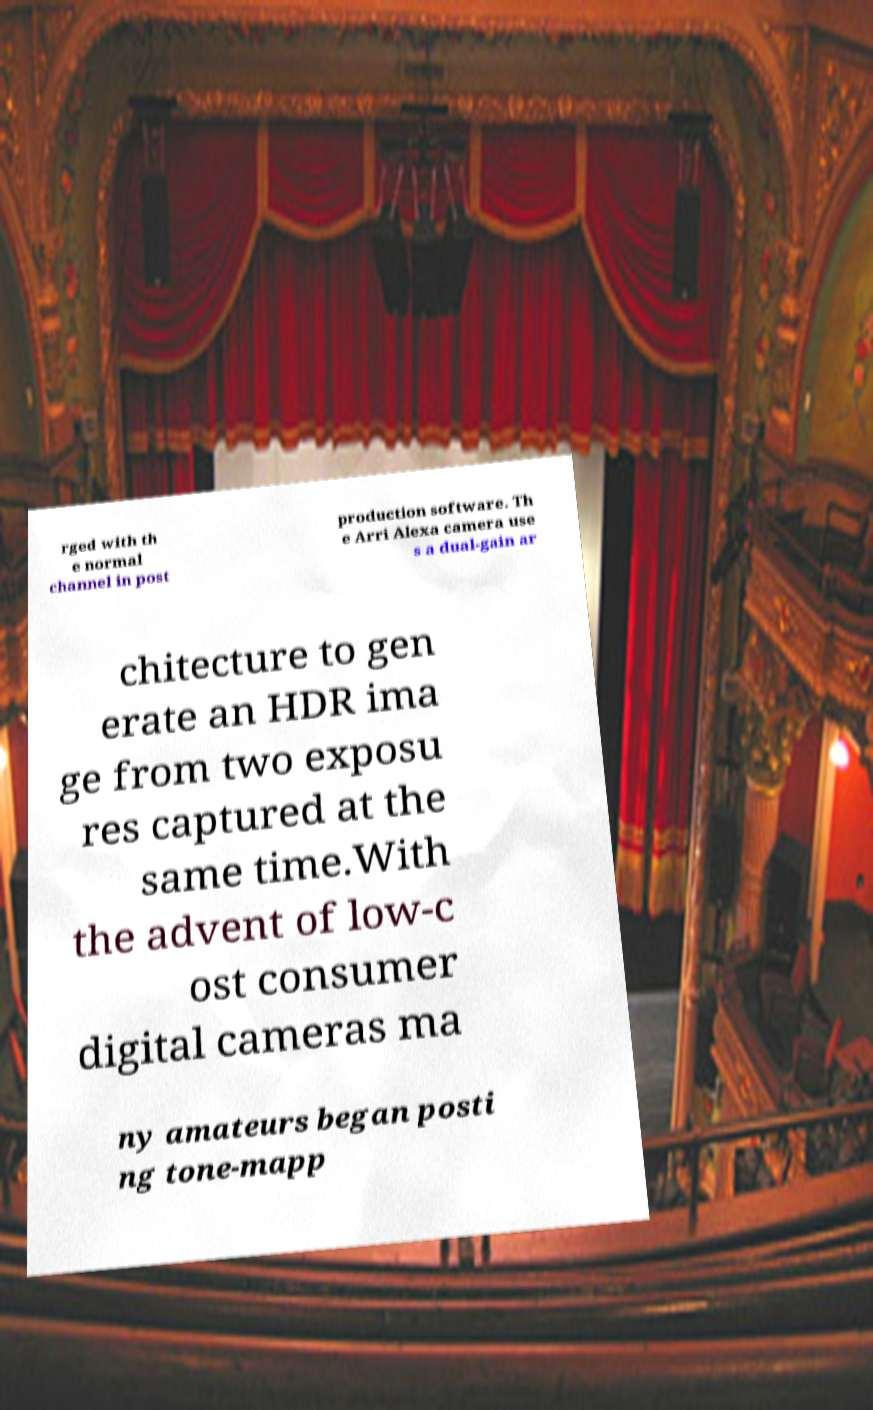Could you extract and type out the text from this image? rged with th e normal channel in post production software. Th e Arri Alexa camera use s a dual-gain ar chitecture to gen erate an HDR ima ge from two exposu res captured at the same time.With the advent of low-c ost consumer digital cameras ma ny amateurs began posti ng tone-mapp 